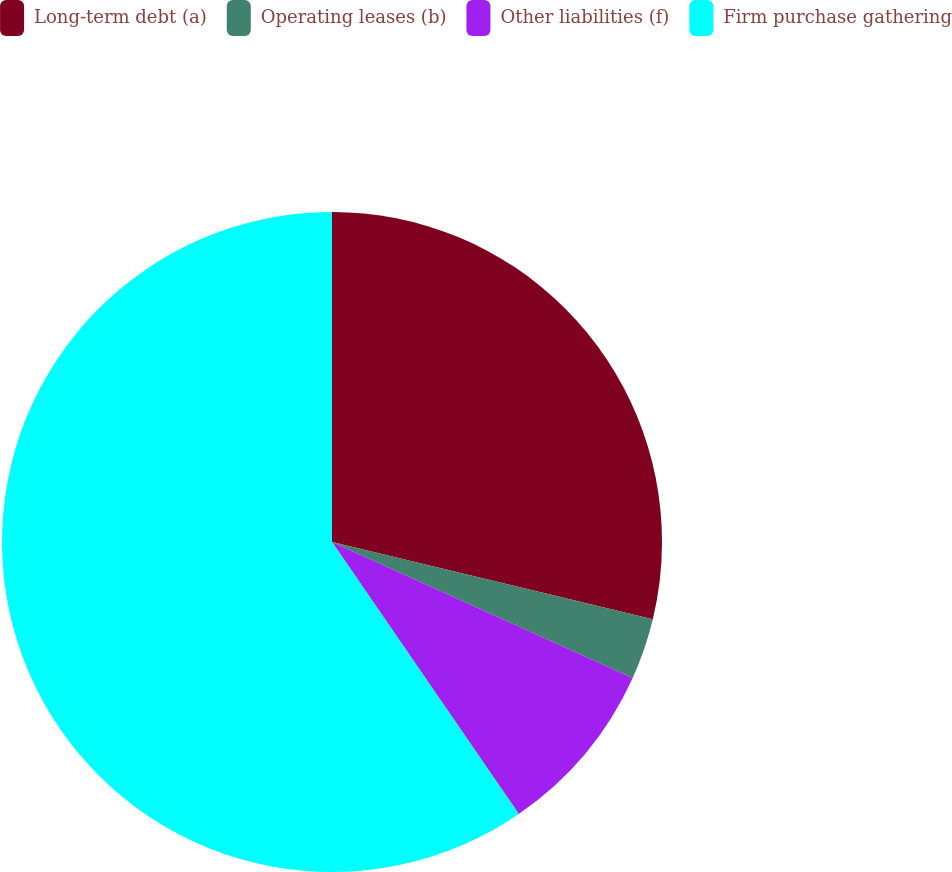Convert chart to OTSL. <chart><loc_0><loc_0><loc_500><loc_500><pie_chart><fcel>Long-term debt (a)<fcel>Operating leases (b)<fcel>Other liabilities (f)<fcel>Firm purchase gathering<nl><fcel>28.76%<fcel>3.0%<fcel>8.66%<fcel>59.57%<nl></chart> 